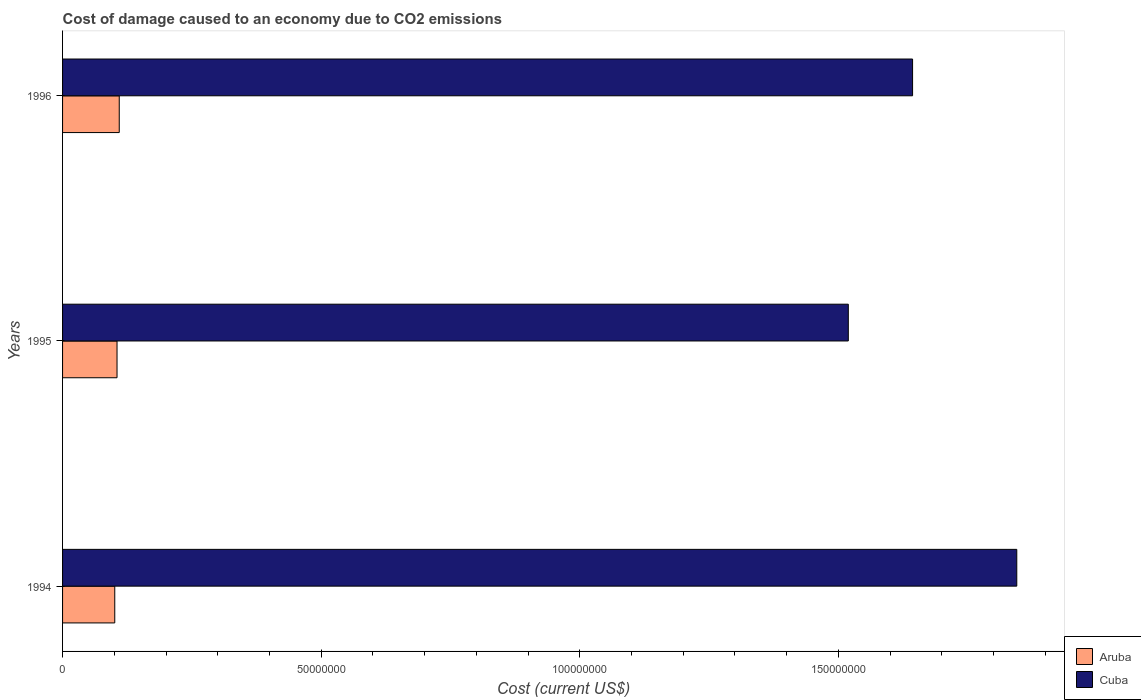Are the number of bars per tick equal to the number of legend labels?
Keep it short and to the point. Yes. How many bars are there on the 3rd tick from the bottom?
Provide a succinct answer. 2. What is the cost of damage caused due to CO2 emissisons in Aruba in 1996?
Keep it short and to the point. 1.10e+07. Across all years, what is the maximum cost of damage caused due to CO2 emissisons in Cuba?
Offer a terse response. 1.85e+08. Across all years, what is the minimum cost of damage caused due to CO2 emissisons in Aruba?
Ensure brevity in your answer.  1.01e+07. In which year was the cost of damage caused due to CO2 emissisons in Aruba maximum?
Your answer should be compact. 1996. In which year was the cost of damage caused due to CO2 emissisons in Cuba minimum?
Your answer should be very brief. 1995. What is the total cost of damage caused due to CO2 emissisons in Aruba in the graph?
Provide a short and direct response. 3.16e+07. What is the difference between the cost of damage caused due to CO2 emissisons in Cuba in 1994 and that in 1996?
Your response must be concise. 2.01e+07. What is the difference between the cost of damage caused due to CO2 emissisons in Cuba in 1994 and the cost of damage caused due to CO2 emissisons in Aruba in 1995?
Provide a succinct answer. 1.74e+08. What is the average cost of damage caused due to CO2 emissisons in Cuba per year?
Make the answer very short. 1.67e+08. In the year 1996, what is the difference between the cost of damage caused due to CO2 emissisons in Aruba and cost of damage caused due to CO2 emissisons in Cuba?
Ensure brevity in your answer.  -1.53e+08. What is the ratio of the cost of damage caused due to CO2 emissisons in Aruba in 1994 to that in 1995?
Offer a terse response. 0.96. Is the cost of damage caused due to CO2 emissisons in Aruba in 1994 less than that in 1995?
Make the answer very short. Yes. Is the difference between the cost of damage caused due to CO2 emissisons in Aruba in 1995 and 1996 greater than the difference between the cost of damage caused due to CO2 emissisons in Cuba in 1995 and 1996?
Your response must be concise. Yes. What is the difference between the highest and the second highest cost of damage caused due to CO2 emissisons in Cuba?
Offer a very short reply. 2.01e+07. What is the difference between the highest and the lowest cost of damage caused due to CO2 emissisons in Aruba?
Your answer should be very brief. 8.70e+05. What does the 2nd bar from the top in 1994 represents?
Keep it short and to the point. Aruba. What does the 1st bar from the bottom in 1996 represents?
Your answer should be compact. Aruba. How many bars are there?
Offer a very short reply. 6. Are all the bars in the graph horizontal?
Provide a succinct answer. Yes. How many years are there in the graph?
Your answer should be compact. 3. What is the difference between two consecutive major ticks on the X-axis?
Your response must be concise. 5.00e+07. Are the values on the major ticks of X-axis written in scientific E-notation?
Give a very brief answer. No. Where does the legend appear in the graph?
Offer a terse response. Bottom right. How are the legend labels stacked?
Your answer should be very brief. Vertical. What is the title of the graph?
Your response must be concise. Cost of damage caused to an economy due to CO2 emissions. Does "Austria" appear as one of the legend labels in the graph?
Offer a very short reply. No. What is the label or title of the X-axis?
Offer a terse response. Cost (current US$). What is the Cost (current US$) in Aruba in 1994?
Your response must be concise. 1.01e+07. What is the Cost (current US$) of Cuba in 1994?
Offer a very short reply. 1.85e+08. What is the Cost (current US$) of Aruba in 1995?
Ensure brevity in your answer.  1.05e+07. What is the Cost (current US$) of Cuba in 1995?
Offer a terse response. 1.52e+08. What is the Cost (current US$) of Aruba in 1996?
Keep it short and to the point. 1.10e+07. What is the Cost (current US$) in Cuba in 1996?
Your answer should be very brief. 1.64e+08. Across all years, what is the maximum Cost (current US$) of Aruba?
Provide a short and direct response. 1.10e+07. Across all years, what is the maximum Cost (current US$) of Cuba?
Your response must be concise. 1.85e+08. Across all years, what is the minimum Cost (current US$) of Aruba?
Your answer should be compact. 1.01e+07. Across all years, what is the minimum Cost (current US$) in Cuba?
Give a very brief answer. 1.52e+08. What is the total Cost (current US$) of Aruba in the graph?
Offer a terse response. 3.16e+07. What is the total Cost (current US$) in Cuba in the graph?
Keep it short and to the point. 5.01e+08. What is the difference between the Cost (current US$) of Aruba in 1994 and that in 1995?
Your response must be concise. -4.40e+05. What is the difference between the Cost (current US$) of Cuba in 1994 and that in 1995?
Make the answer very short. 3.26e+07. What is the difference between the Cost (current US$) in Aruba in 1994 and that in 1996?
Make the answer very short. -8.70e+05. What is the difference between the Cost (current US$) of Cuba in 1994 and that in 1996?
Give a very brief answer. 2.01e+07. What is the difference between the Cost (current US$) of Aruba in 1995 and that in 1996?
Your response must be concise. -4.30e+05. What is the difference between the Cost (current US$) in Cuba in 1995 and that in 1996?
Offer a very short reply. -1.24e+07. What is the difference between the Cost (current US$) of Aruba in 1994 and the Cost (current US$) of Cuba in 1995?
Provide a short and direct response. -1.42e+08. What is the difference between the Cost (current US$) in Aruba in 1994 and the Cost (current US$) in Cuba in 1996?
Keep it short and to the point. -1.54e+08. What is the difference between the Cost (current US$) of Aruba in 1995 and the Cost (current US$) of Cuba in 1996?
Your response must be concise. -1.54e+08. What is the average Cost (current US$) in Aruba per year?
Your answer should be very brief. 1.05e+07. What is the average Cost (current US$) in Cuba per year?
Keep it short and to the point. 1.67e+08. In the year 1994, what is the difference between the Cost (current US$) in Aruba and Cost (current US$) in Cuba?
Provide a short and direct response. -1.74e+08. In the year 1995, what is the difference between the Cost (current US$) of Aruba and Cost (current US$) of Cuba?
Offer a terse response. -1.41e+08. In the year 1996, what is the difference between the Cost (current US$) in Aruba and Cost (current US$) in Cuba?
Your response must be concise. -1.53e+08. What is the ratio of the Cost (current US$) of Aruba in 1994 to that in 1995?
Your answer should be very brief. 0.96. What is the ratio of the Cost (current US$) of Cuba in 1994 to that in 1995?
Offer a very short reply. 1.21. What is the ratio of the Cost (current US$) of Aruba in 1994 to that in 1996?
Ensure brevity in your answer.  0.92. What is the ratio of the Cost (current US$) of Cuba in 1994 to that in 1996?
Offer a terse response. 1.12. What is the ratio of the Cost (current US$) of Aruba in 1995 to that in 1996?
Your answer should be very brief. 0.96. What is the ratio of the Cost (current US$) of Cuba in 1995 to that in 1996?
Offer a terse response. 0.92. What is the difference between the highest and the second highest Cost (current US$) in Aruba?
Give a very brief answer. 4.30e+05. What is the difference between the highest and the second highest Cost (current US$) of Cuba?
Ensure brevity in your answer.  2.01e+07. What is the difference between the highest and the lowest Cost (current US$) in Aruba?
Provide a short and direct response. 8.70e+05. What is the difference between the highest and the lowest Cost (current US$) of Cuba?
Your answer should be compact. 3.26e+07. 